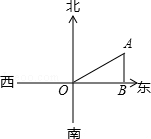In the figure, there is an east-west road in front of Xiaoya's house (point O in the figure), and it is measured that there is a water tower (point A in the figure) at 60.0 degrees 2000.0 east of the north of her house, then the location of the water tower The distance to the highway AB is () To accurately determine the distance AB from the water tower to the highway, we need to apply trigonometric principles to the information provided. Given that point A represents the water tower and is located at a 60-degree angle east of the north of Xiaoya's house at point O, and the distance OA is 2000.0 meters, we can use the sine function to calculate AB. Since sin(60) = √3/2, the distance AB is 2000 * sin(60) which equals 2000 * √3/2 = 1000√3 meters. This calculation reveals that the correct answer is option B: 1000√3. 